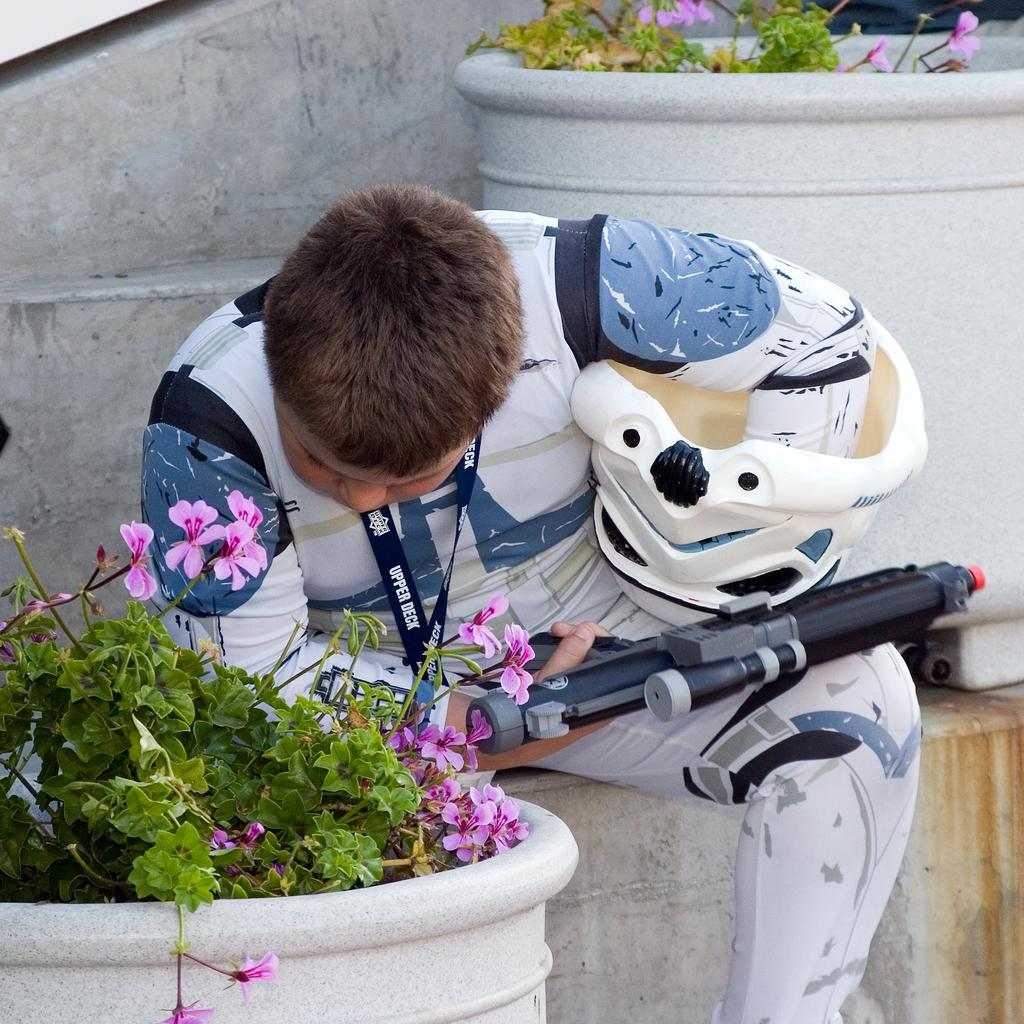What is the main subject of the image? There is a person in the image. What is the person holding in the image? The person is holding a weapon toy. What else can be seen in the image besides the person? There are plants in the image. What type of seat is visible in the image? There is no seat present in the image. What scientific theory can be observed in the image? There is no scientific theory depicted in the image. 